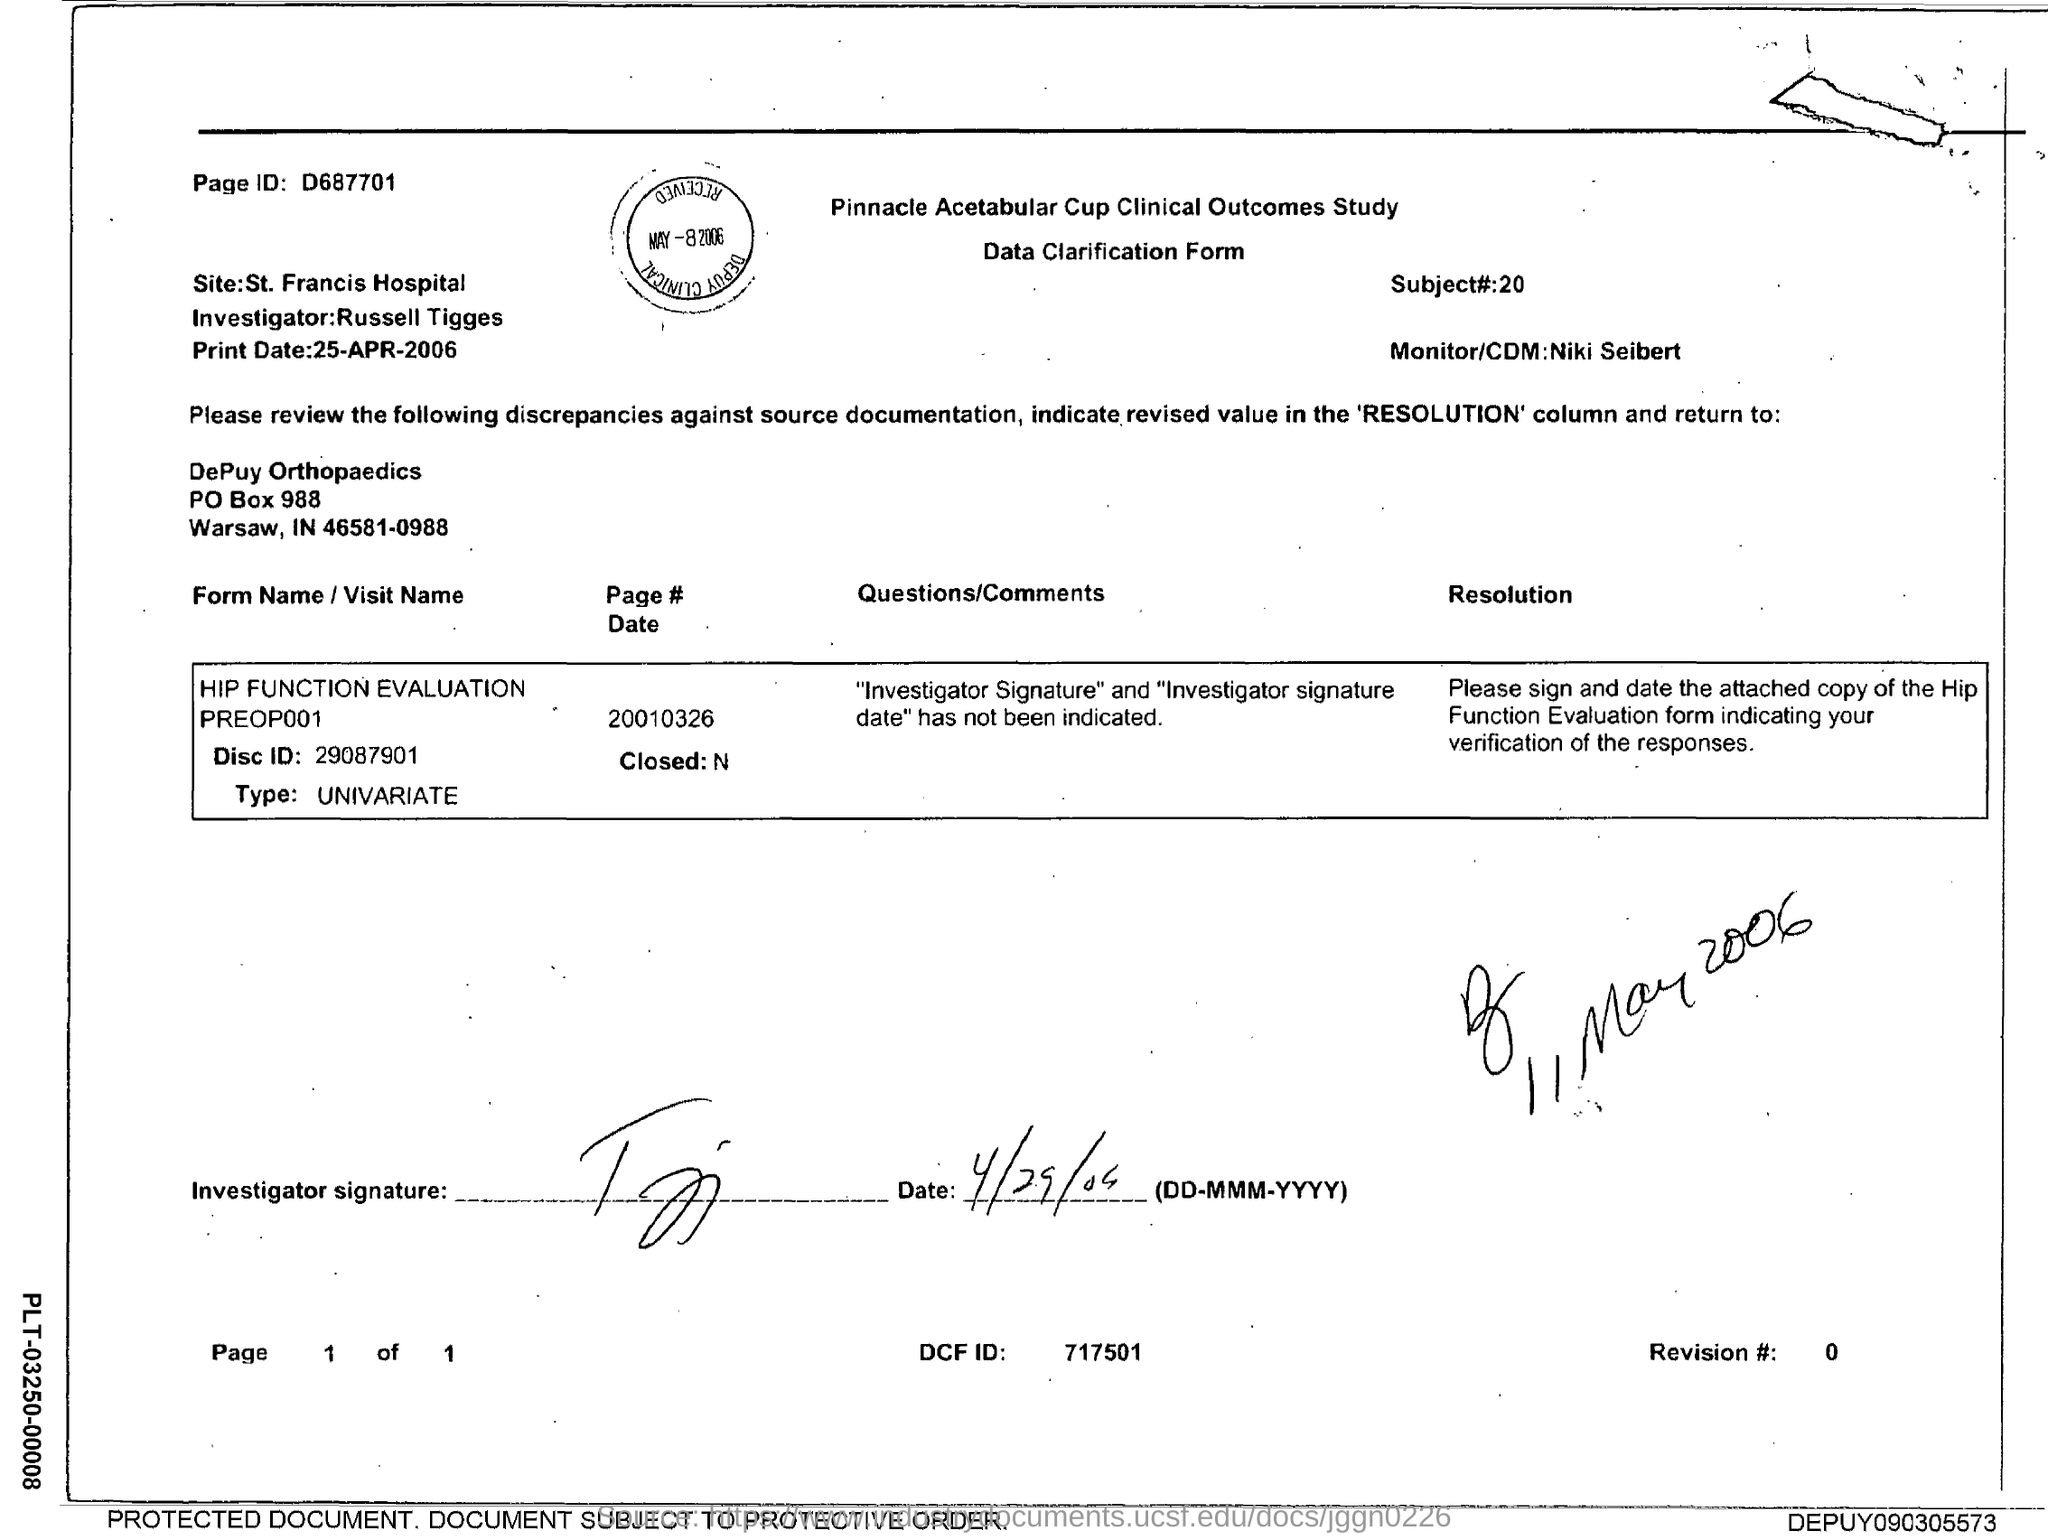What is the page ID mentioned in this document?
Make the answer very short. D687701. 